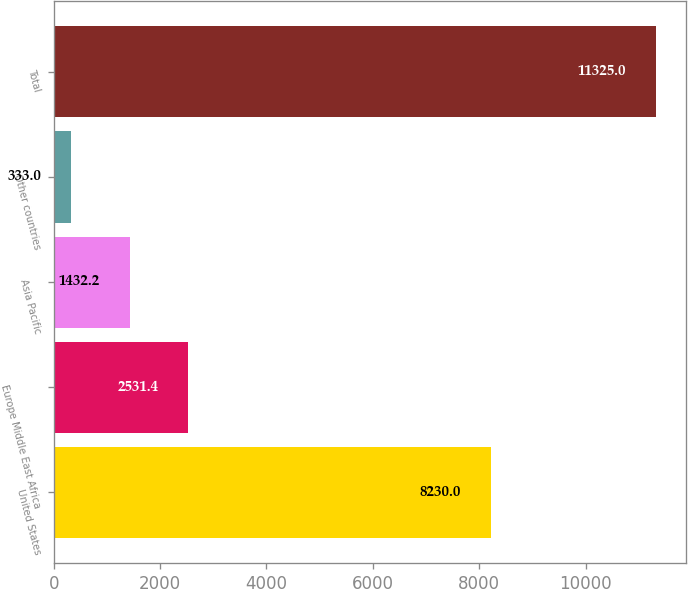Convert chart to OTSL. <chart><loc_0><loc_0><loc_500><loc_500><bar_chart><fcel>United States<fcel>Europe Middle East Africa<fcel>Asia Pacific<fcel>Other countries<fcel>Total<nl><fcel>8230<fcel>2531.4<fcel>1432.2<fcel>333<fcel>11325<nl></chart> 